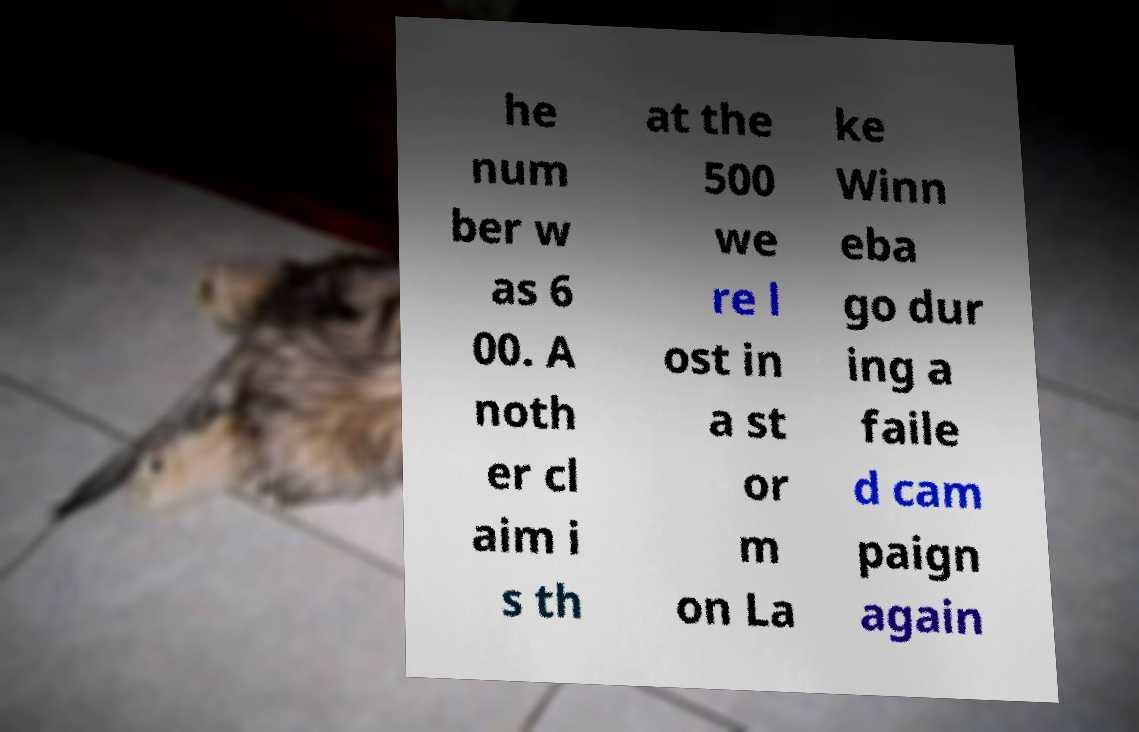Can you read and provide the text displayed in the image?This photo seems to have some interesting text. Can you extract and type it out for me? he num ber w as 6 00. A noth er cl aim i s th at the 500 we re l ost in a st or m on La ke Winn eba go dur ing a faile d cam paign again 